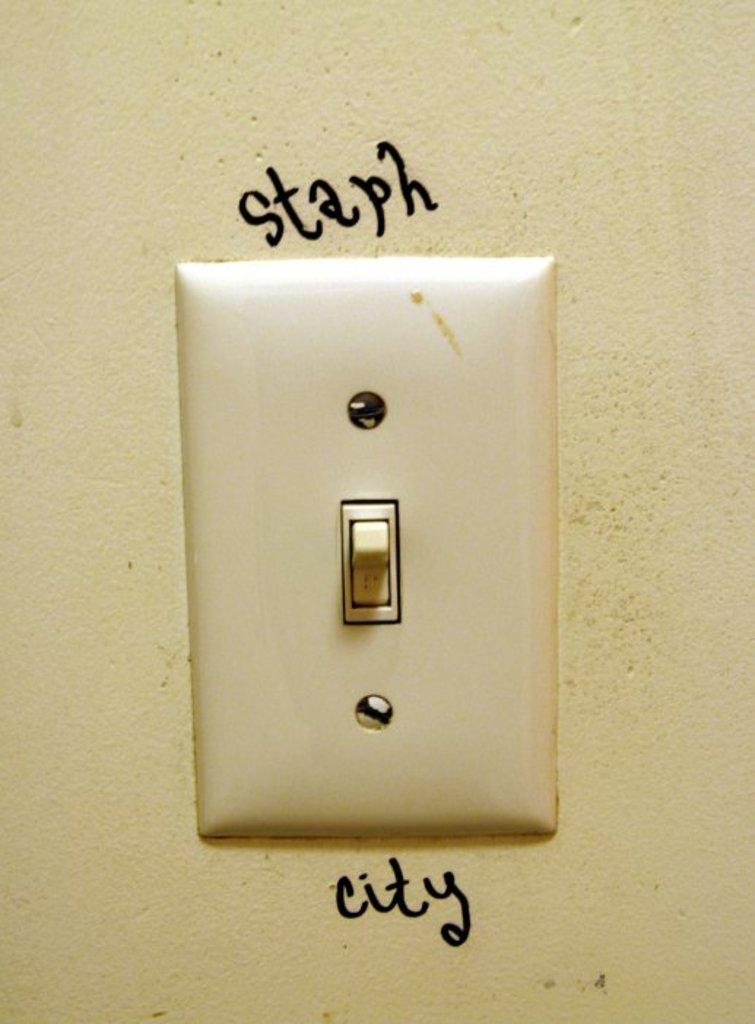Provide a one-sentence caption for the provided image. a light switch with the word staph on top and city on the bottom. 